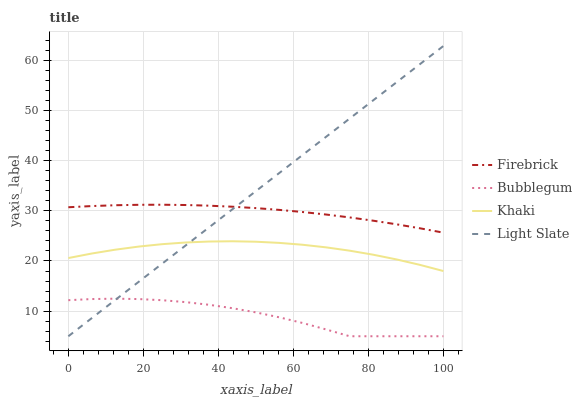Does Bubblegum have the minimum area under the curve?
Answer yes or no. Yes. Does Light Slate have the maximum area under the curve?
Answer yes or no. Yes. Does Firebrick have the minimum area under the curve?
Answer yes or no. No. Does Firebrick have the maximum area under the curve?
Answer yes or no. No. Is Light Slate the smoothest?
Answer yes or no. Yes. Is Bubblegum the roughest?
Answer yes or no. Yes. Is Firebrick the smoothest?
Answer yes or no. No. Is Firebrick the roughest?
Answer yes or no. No. Does Light Slate have the lowest value?
Answer yes or no. Yes. Does Khaki have the lowest value?
Answer yes or no. No. Does Light Slate have the highest value?
Answer yes or no. Yes. Does Firebrick have the highest value?
Answer yes or no. No. Is Bubblegum less than Khaki?
Answer yes or no. Yes. Is Firebrick greater than Khaki?
Answer yes or no. Yes. Does Bubblegum intersect Light Slate?
Answer yes or no. Yes. Is Bubblegum less than Light Slate?
Answer yes or no. No. Is Bubblegum greater than Light Slate?
Answer yes or no. No. Does Bubblegum intersect Khaki?
Answer yes or no. No. 